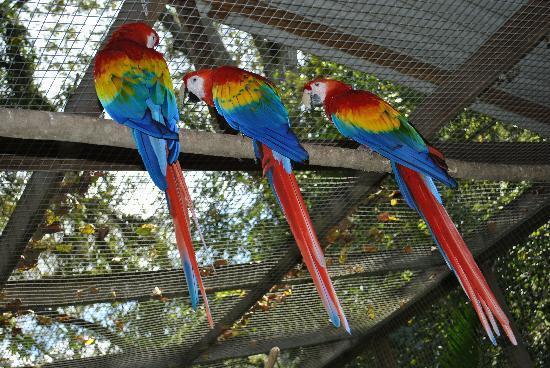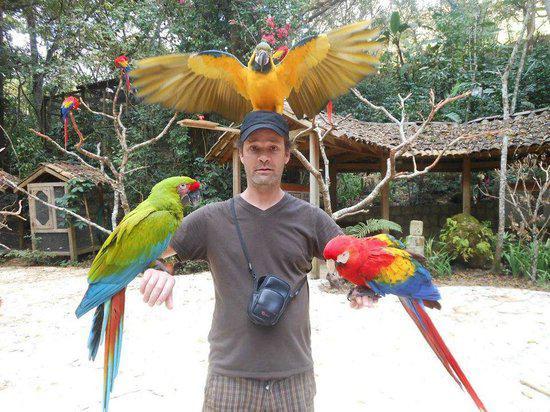The first image is the image on the left, the second image is the image on the right. Examine the images to the left and right. Is the description "There is one predominately red bird perched in the image on the left." accurate? Answer yes or no. No. The first image is the image on the left, the second image is the image on the right. Considering the images on both sides, is "No image contains more than two parrot-type birds, and each image contains exactly one red-headed bird." valid? Answer yes or no. No. 